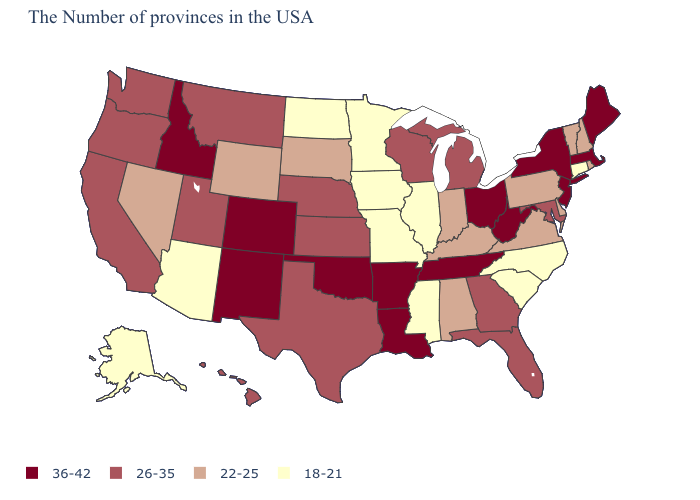Does Delaware have the highest value in the USA?
Concise answer only. No. Name the states that have a value in the range 22-25?
Keep it brief. Rhode Island, New Hampshire, Vermont, Delaware, Pennsylvania, Virginia, Kentucky, Indiana, Alabama, South Dakota, Wyoming, Nevada. What is the value of New York?
Write a very short answer. 36-42. Does the first symbol in the legend represent the smallest category?
Answer briefly. No. Name the states that have a value in the range 26-35?
Short answer required. Maryland, Florida, Georgia, Michigan, Wisconsin, Kansas, Nebraska, Texas, Utah, Montana, California, Washington, Oregon, Hawaii. What is the highest value in the USA?
Be succinct. 36-42. Name the states that have a value in the range 22-25?
Short answer required. Rhode Island, New Hampshire, Vermont, Delaware, Pennsylvania, Virginia, Kentucky, Indiana, Alabama, South Dakota, Wyoming, Nevada. Name the states that have a value in the range 26-35?
Be succinct. Maryland, Florida, Georgia, Michigan, Wisconsin, Kansas, Nebraska, Texas, Utah, Montana, California, Washington, Oregon, Hawaii. Which states have the lowest value in the West?
Answer briefly. Arizona, Alaska. Does Vermont have a higher value than South Dakota?
Answer briefly. No. Does Tennessee have the highest value in the USA?
Short answer required. Yes. How many symbols are there in the legend?
Quick response, please. 4. Among the states that border Kentucky , does Virginia have the highest value?
Short answer required. No. Which states have the lowest value in the Northeast?
Quick response, please. Connecticut. Does New Jersey have a higher value than Maryland?
Concise answer only. Yes. 